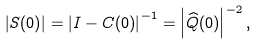Convert formula to latex. <formula><loc_0><loc_0><loc_500><loc_500>\left | { S } ( 0 ) \right | = \left | { I } - { C } ( 0 ) \right | ^ { - 1 } = \left | \widehat { Q } ( 0 ) \right | ^ { - 2 } ,</formula> 